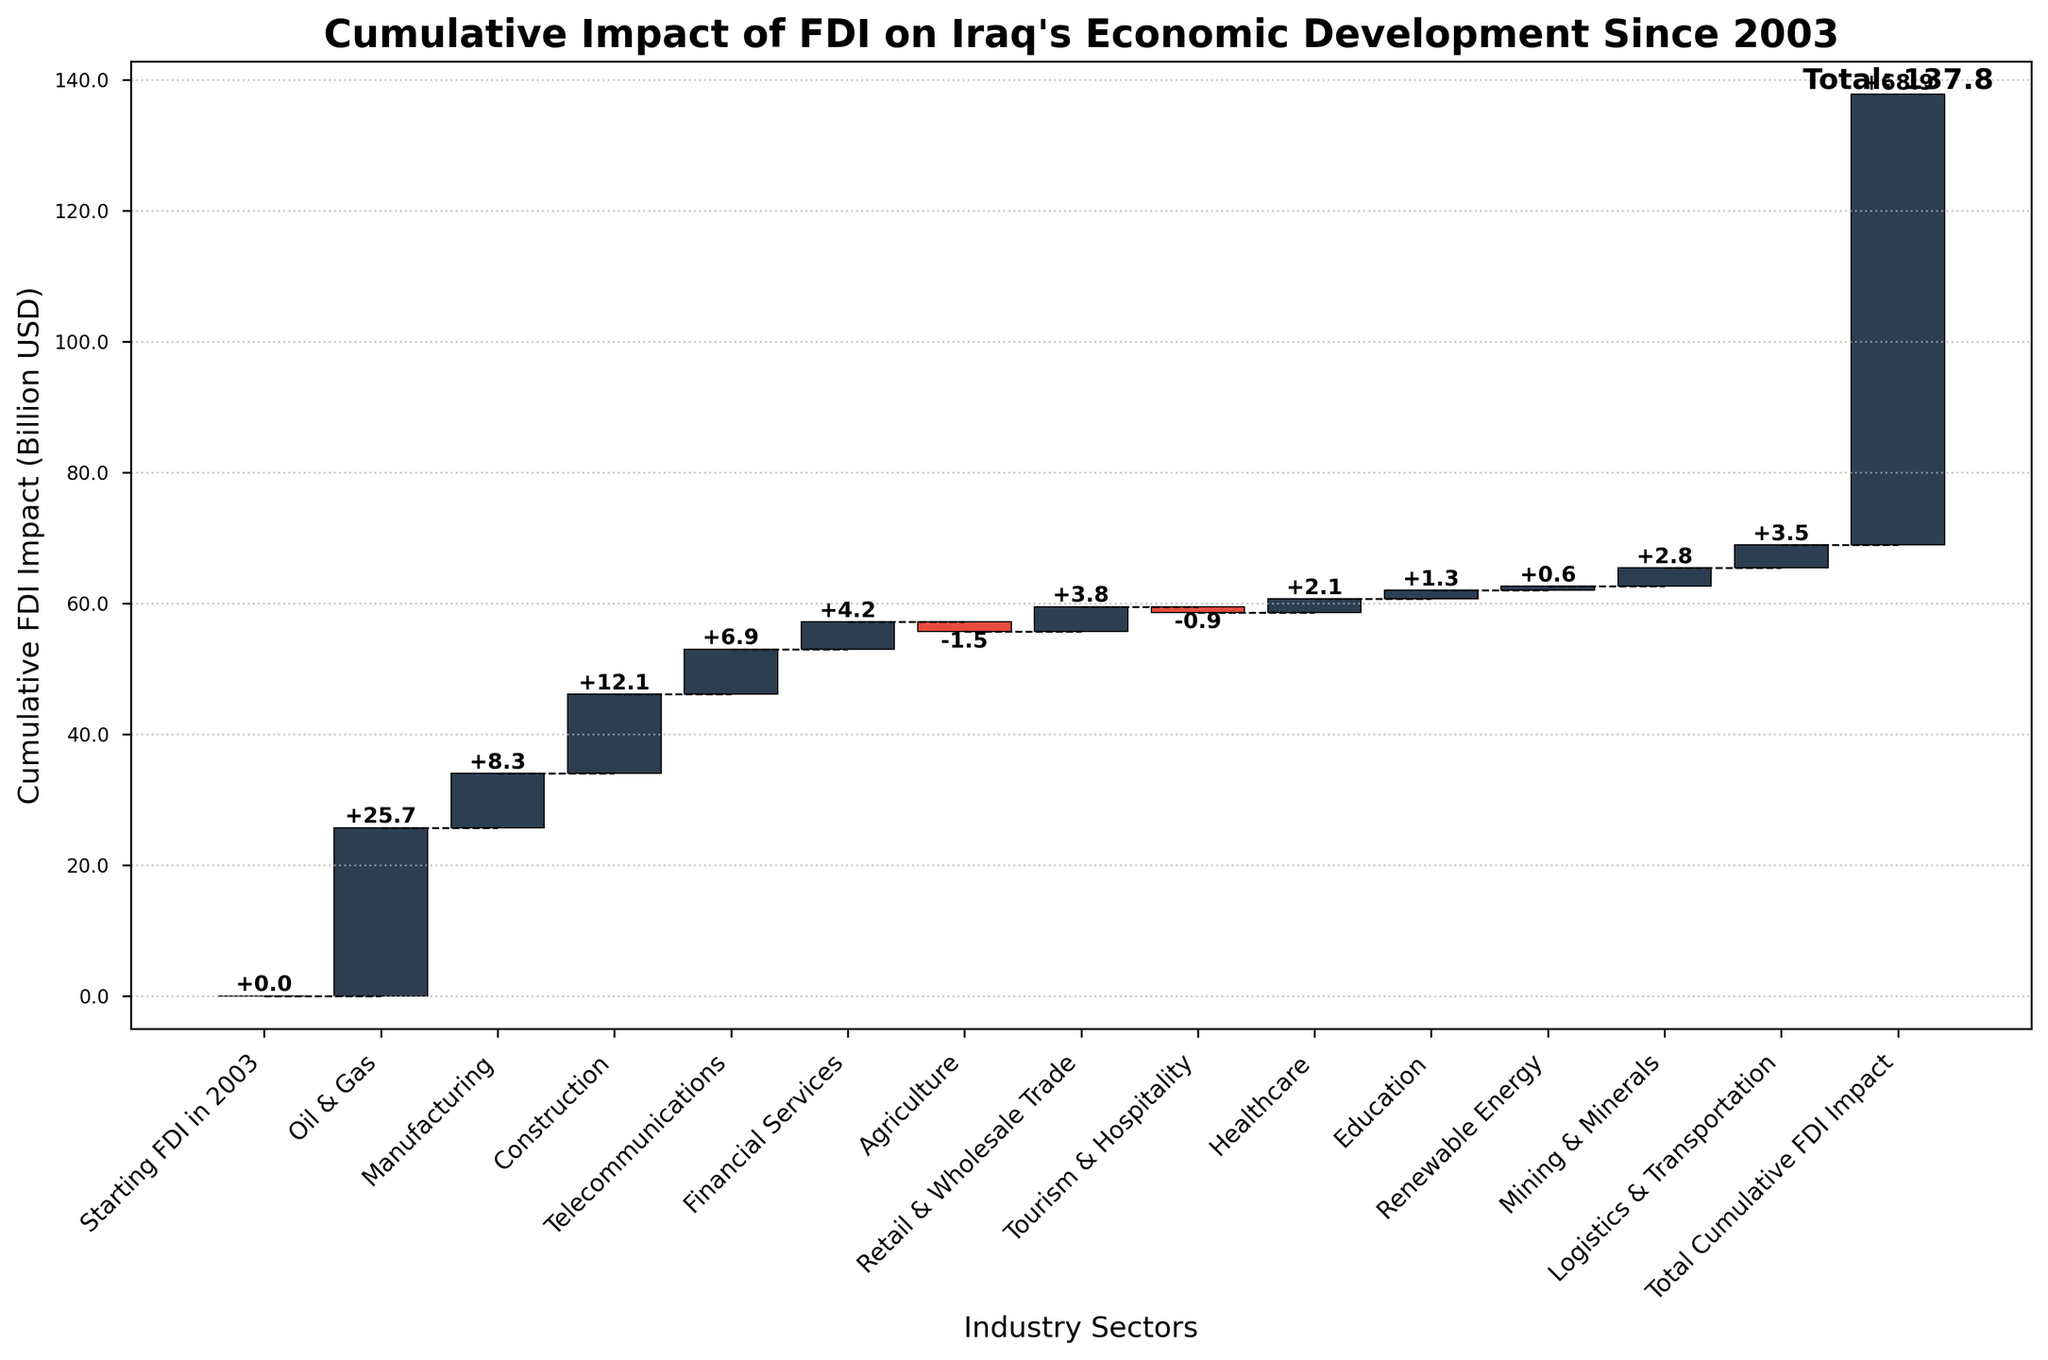What is the title of the chart? The title is displayed at the top of the chart. It reads: "Cumulative Impact of FDI on Iraq's Economic Development Since 2003."
Answer: Cumulative Impact of FDI on Iraq's Economic Development Since 2003 What is the cumulative FDI impact for the Manufacturing sector? Locate the bar corresponding to the Manufacturing sector. The value label on the bar shows the cumulative impact.
Answer: 8.3 Which sector has the highest positive FDI impact? Compare all the positive values in the bars and identify the highest one. The Oil & Gas sector has the highest positive FDI impact.
Answer: Oil & Gas How much is the cumulative FDI impact when combining Healthcare, Education, and Renewable Energy? Sum the values of Healthcare (2.1), Education (1.3), and Renewable Energy (0.6). The cumulative effect is 2.1 + 1.3 + 0.6 = 4.0.
Answer: 4.0 Which two sectors have a negative impact on the cumulative FDI? Identify the bars with negative values. Agriculture and Tourism & Hospitality have negative impacts.
Answer: Agriculture and Tourism & Hospitality By how much does the Financial Services sector contribute to the cumulative FDI impact compared to the Retail & Wholesale Trade sector? Subtract the value of Retail & Wholesale Trade from Financial Services to find the difference: 4.2 - 3.8 = 0.4.
Answer: 0.4 What is the net impact of the Oil & Gas and Construction sectors together? Sum the values of Oil & Gas (25.7) and Construction (12.1). The net impact is 25.7 + 12.1 = 37.8.
Answer: 37.8 Considering the starting FDI in 2003, what was the cumulative FDI impact after the Construction sector’s incorporation? Sum the values starting from 0 (Starting FDI in 2003), Oil & Gas (25.7), Manufacturing (8.3), and Construction (12.1). The cumulative FDI impact after Construction is: 0 + 25.7 + 8.3 + 12.1 = 46.1.
Answer: 46.1 How does the impact of Telecommunications compare to the impact of Mining & Minerals? Compare the values of Telecommunications (6.9) and Mining & Minerals (2.8). Telecommunications has a higher impact.
Answer: Telecommunications What is the overall cumulative FDI impact at the end as shown in the chart? The last bar represents the total cumulative FDI impact, which is labeled as 68.9.
Answer: 68.9 